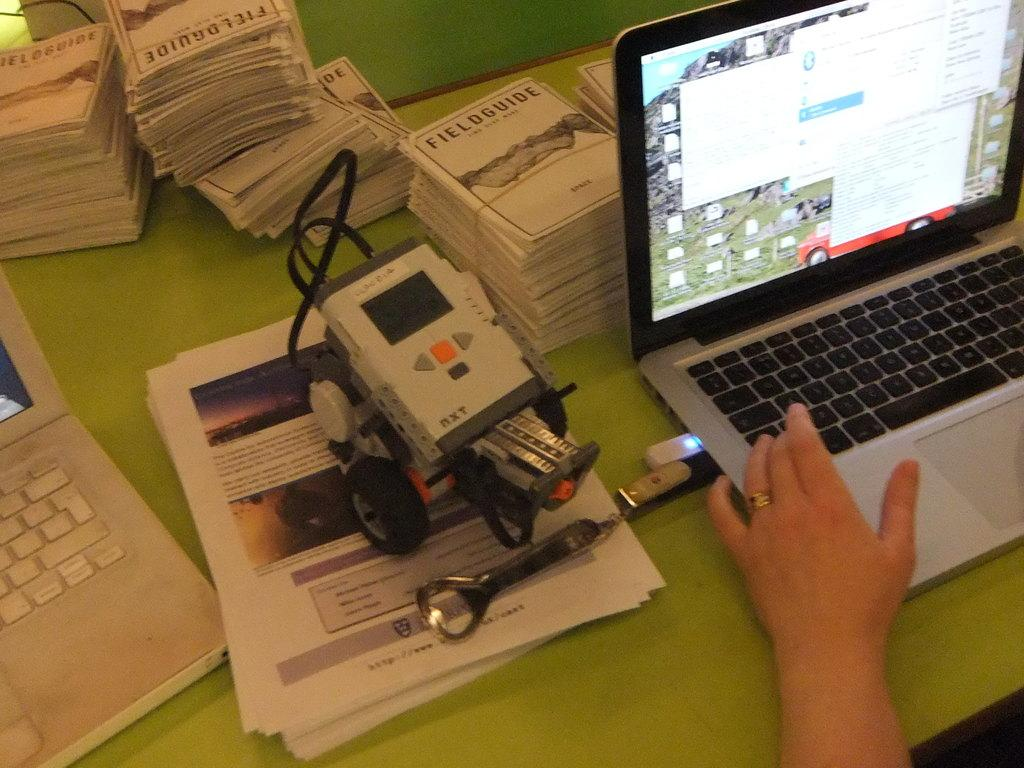Provide a one-sentence caption for the provided image. A view of a green desk with a person on a computer and a stack of Fieldguides. 